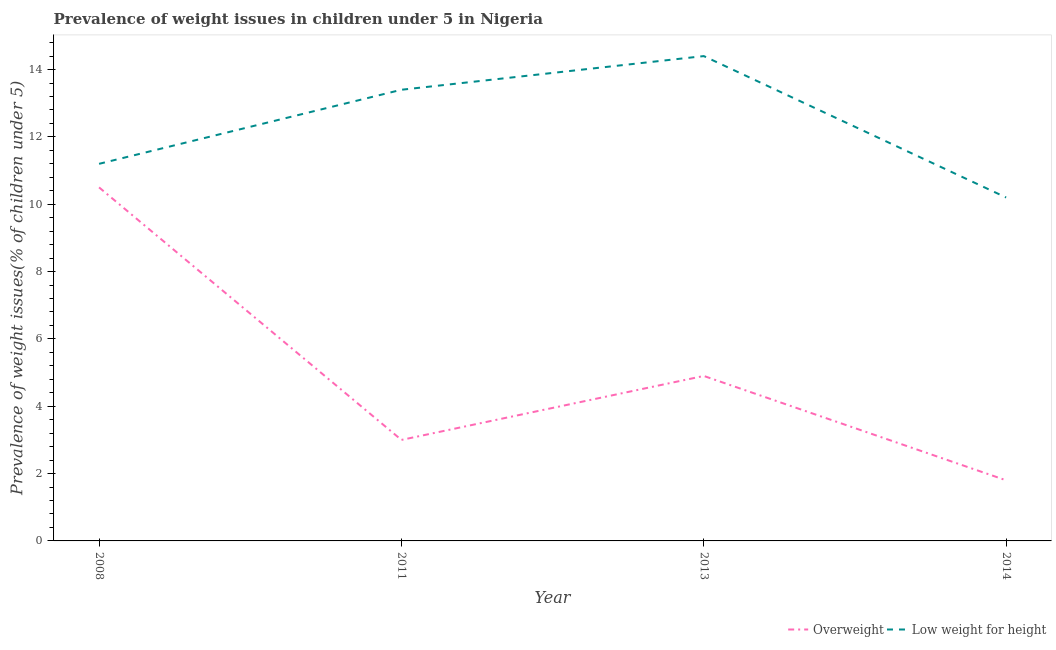How many different coloured lines are there?
Your answer should be compact. 2. What is the percentage of overweight children in 2008?
Offer a terse response. 10.5. Across all years, what is the maximum percentage of underweight children?
Provide a succinct answer. 14.4. Across all years, what is the minimum percentage of overweight children?
Ensure brevity in your answer.  1.8. In which year was the percentage of underweight children maximum?
Ensure brevity in your answer.  2013. What is the total percentage of underweight children in the graph?
Keep it short and to the point. 49.2. What is the difference between the percentage of underweight children in 2008 and that in 2013?
Your answer should be very brief. -3.2. What is the difference between the percentage of overweight children in 2008 and the percentage of underweight children in 2014?
Provide a succinct answer. 0.3. What is the average percentage of overweight children per year?
Your response must be concise. 5.05. In the year 2008, what is the difference between the percentage of underweight children and percentage of overweight children?
Keep it short and to the point. 0.7. What is the ratio of the percentage of underweight children in 2008 to that in 2014?
Offer a terse response. 1.1. What is the difference between the highest and the second highest percentage of underweight children?
Offer a very short reply. 1. What is the difference between the highest and the lowest percentage of overweight children?
Your answer should be very brief. 8.7. Is the sum of the percentage of overweight children in 2008 and 2014 greater than the maximum percentage of underweight children across all years?
Make the answer very short. No. Does the percentage of overweight children monotonically increase over the years?
Make the answer very short. No. Is the percentage of overweight children strictly less than the percentage of underweight children over the years?
Provide a short and direct response. Yes. How many years are there in the graph?
Offer a terse response. 4. Does the graph contain any zero values?
Your response must be concise. No. Where does the legend appear in the graph?
Keep it short and to the point. Bottom right. How are the legend labels stacked?
Give a very brief answer. Horizontal. What is the title of the graph?
Give a very brief answer. Prevalence of weight issues in children under 5 in Nigeria. What is the label or title of the X-axis?
Offer a very short reply. Year. What is the label or title of the Y-axis?
Offer a terse response. Prevalence of weight issues(% of children under 5). What is the Prevalence of weight issues(% of children under 5) of Low weight for height in 2008?
Your answer should be very brief. 11.2. What is the Prevalence of weight issues(% of children under 5) of Low weight for height in 2011?
Keep it short and to the point. 13.4. What is the Prevalence of weight issues(% of children under 5) of Overweight in 2013?
Make the answer very short. 4.9. What is the Prevalence of weight issues(% of children under 5) of Low weight for height in 2013?
Keep it short and to the point. 14.4. What is the Prevalence of weight issues(% of children under 5) in Overweight in 2014?
Ensure brevity in your answer.  1.8. What is the Prevalence of weight issues(% of children under 5) in Low weight for height in 2014?
Provide a short and direct response. 10.2. Across all years, what is the maximum Prevalence of weight issues(% of children under 5) in Overweight?
Give a very brief answer. 10.5. Across all years, what is the maximum Prevalence of weight issues(% of children under 5) of Low weight for height?
Your answer should be compact. 14.4. Across all years, what is the minimum Prevalence of weight issues(% of children under 5) of Overweight?
Your answer should be compact. 1.8. Across all years, what is the minimum Prevalence of weight issues(% of children under 5) of Low weight for height?
Offer a terse response. 10.2. What is the total Prevalence of weight issues(% of children under 5) in Overweight in the graph?
Offer a very short reply. 20.2. What is the total Prevalence of weight issues(% of children under 5) in Low weight for height in the graph?
Provide a succinct answer. 49.2. What is the difference between the Prevalence of weight issues(% of children under 5) in Overweight in 2008 and that in 2013?
Keep it short and to the point. 5.6. What is the difference between the Prevalence of weight issues(% of children under 5) in Low weight for height in 2008 and that in 2014?
Your answer should be very brief. 1. What is the difference between the Prevalence of weight issues(% of children under 5) of Overweight in 2011 and that in 2013?
Make the answer very short. -1.9. What is the difference between the Prevalence of weight issues(% of children under 5) of Low weight for height in 2011 and that in 2013?
Keep it short and to the point. -1. What is the difference between the Prevalence of weight issues(% of children under 5) in Overweight in 2011 and that in 2014?
Offer a very short reply. 1.2. What is the difference between the Prevalence of weight issues(% of children under 5) in Low weight for height in 2013 and that in 2014?
Provide a short and direct response. 4.2. What is the difference between the Prevalence of weight issues(% of children under 5) of Overweight in 2008 and the Prevalence of weight issues(% of children under 5) of Low weight for height in 2011?
Your response must be concise. -2.9. What is the difference between the Prevalence of weight issues(% of children under 5) of Overweight in 2008 and the Prevalence of weight issues(% of children under 5) of Low weight for height in 2014?
Provide a succinct answer. 0.3. What is the difference between the Prevalence of weight issues(% of children under 5) in Overweight in 2011 and the Prevalence of weight issues(% of children under 5) in Low weight for height in 2013?
Your answer should be compact. -11.4. What is the difference between the Prevalence of weight issues(% of children under 5) of Overweight in 2011 and the Prevalence of weight issues(% of children under 5) of Low weight for height in 2014?
Ensure brevity in your answer.  -7.2. What is the average Prevalence of weight issues(% of children under 5) in Overweight per year?
Offer a very short reply. 5.05. In the year 2008, what is the difference between the Prevalence of weight issues(% of children under 5) in Overweight and Prevalence of weight issues(% of children under 5) in Low weight for height?
Your answer should be compact. -0.7. In the year 2011, what is the difference between the Prevalence of weight issues(% of children under 5) of Overweight and Prevalence of weight issues(% of children under 5) of Low weight for height?
Ensure brevity in your answer.  -10.4. In the year 2013, what is the difference between the Prevalence of weight issues(% of children under 5) of Overweight and Prevalence of weight issues(% of children under 5) of Low weight for height?
Make the answer very short. -9.5. What is the ratio of the Prevalence of weight issues(% of children under 5) in Low weight for height in 2008 to that in 2011?
Make the answer very short. 0.84. What is the ratio of the Prevalence of weight issues(% of children under 5) of Overweight in 2008 to that in 2013?
Ensure brevity in your answer.  2.14. What is the ratio of the Prevalence of weight issues(% of children under 5) of Overweight in 2008 to that in 2014?
Your answer should be compact. 5.83. What is the ratio of the Prevalence of weight issues(% of children under 5) in Low weight for height in 2008 to that in 2014?
Provide a short and direct response. 1.1. What is the ratio of the Prevalence of weight issues(% of children under 5) in Overweight in 2011 to that in 2013?
Keep it short and to the point. 0.61. What is the ratio of the Prevalence of weight issues(% of children under 5) of Low weight for height in 2011 to that in 2013?
Ensure brevity in your answer.  0.93. What is the ratio of the Prevalence of weight issues(% of children under 5) of Overweight in 2011 to that in 2014?
Your answer should be compact. 1.67. What is the ratio of the Prevalence of weight issues(% of children under 5) in Low weight for height in 2011 to that in 2014?
Provide a short and direct response. 1.31. What is the ratio of the Prevalence of weight issues(% of children under 5) in Overweight in 2013 to that in 2014?
Provide a short and direct response. 2.72. What is the ratio of the Prevalence of weight issues(% of children under 5) in Low weight for height in 2013 to that in 2014?
Give a very brief answer. 1.41. What is the difference between the highest and the lowest Prevalence of weight issues(% of children under 5) in Overweight?
Offer a terse response. 8.7. 